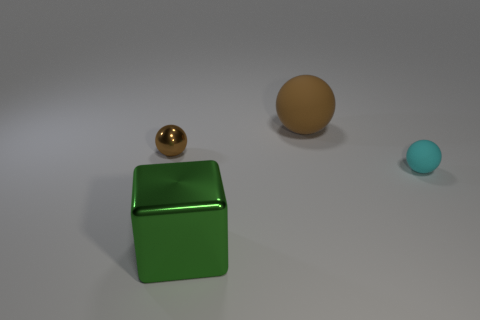Subtract all brown balls. How many balls are left? 1 Add 4 purple metallic objects. How many objects exist? 8 Subtract all blocks. How many objects are left? 3 Subtract 0 cyan blocks. How many objects are left? 4 Subtract all big brown balls. Subtract all brown balls. How many objects are left? 1 Add 1 brown things. How many brown things are left? 3 Add 2 large green metal objects. How many large green metal objects exist? 3 